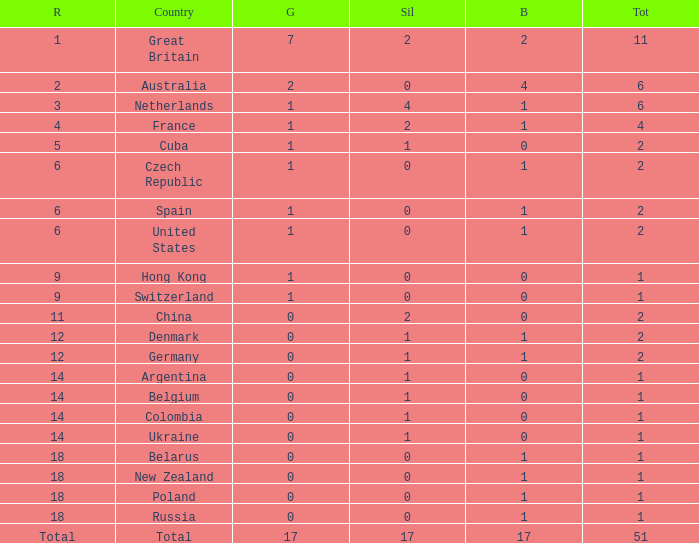Parse the full table. {'header': ['R', 'Country', 'G', 'Sil', 'B', 'Tot'], 'rows': [['1', 'Great Britain', '7', '2', '2', '11'], ['2', 'Australia', '2', '0', '4', '6'], ['3', 'Netherlands', '1', '4', '1', '6'], ['4', 'France', '1', '2', '1', '4'], ['5', 'Cuba', '1', '1', '0', '2'], ['6', 'Czech Republic', '1', '0', '1', '2'], ['6', 'Spain', '1', '0', '1', '2'], ['6', 'United States', '1', '0', '1', '2'], ['9', 'Hong Kong', '1', '0', '0', '1'], ['9', 'Switzerland', '1', '0', '0', '1'], ['11', 'China', '0', '2', '0', '2'], ['12', 'Denmark', '0', '1', '1', '2'], ['12', 'Germany', '0', '1', '1', '2'], ['14', 'Argentina', '0', '1', '0', '1'], ['14', 'Belgium', '0', '1', '0', '1'], ['14', 'Colombia', '0', '1', '0', '1'], ['14', 'Ukraine', '0', '1', '0', '1'], ['18', 'Belarus', '0', '0', '1', '1'], ['18', 'New Zealand', '0', '0', '1', '1'], ['18', 'Poland', '0', '0', '1', '1'], ['18', 'Russia', '0', '0', '1', '1'], ['Total', 'Total', '17', '17', '17', '51']]} Tell me the lowest gold for rank of 6 and total less than 2 None. 